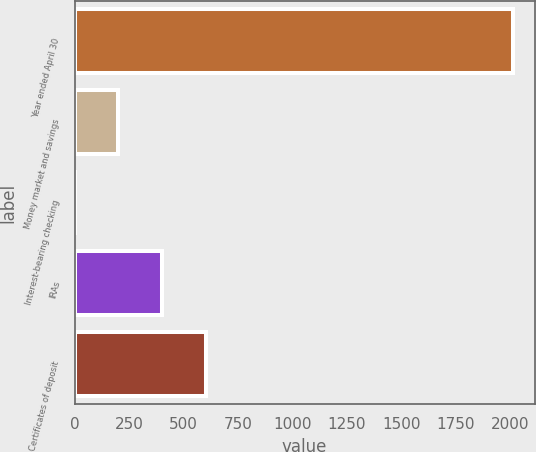Convert chart. <chart><loc_0><loc_0><loc_500><loc_500><bar_chart><fcel>Year ended April 30<fcel>Money market and savings<fcel>Interest-bearing checking<fcel>IRAs<fcel>Certificates of deposit<nl><fcel>2013<fcel>201.45<fcel>0.17<fcel>402.73<fcel>604.01<nl></chart> 